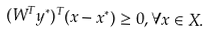Convert formula to latex. <formula><loc_0><loc_0><loc_500><loc_500>( W ^ { T } y ^ { * } ) ^ { T } ( x - x ^ { * } ) \geq 0 , \forall x \in X .</formula> 